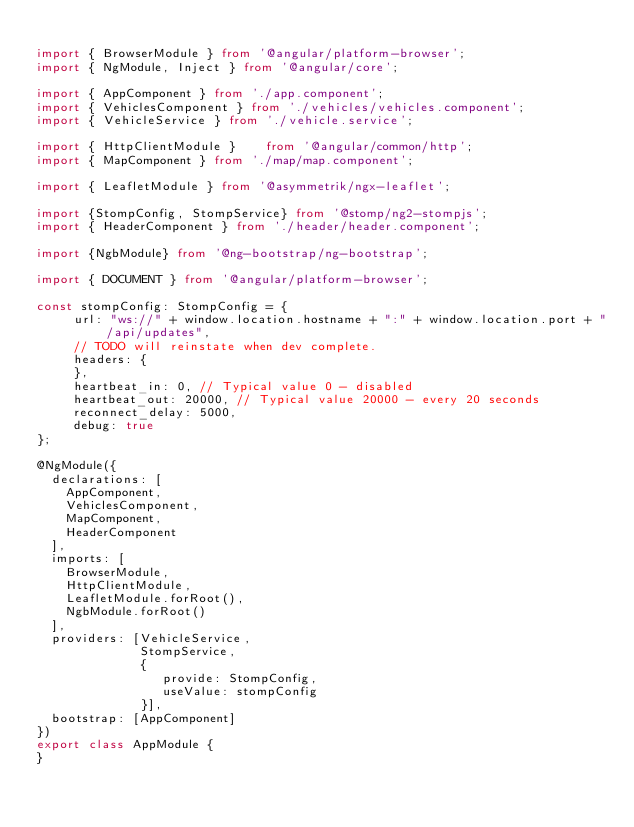<code> <loc_0><loc_0><loc_500><loc_500><_TypeScript_>
import { BrowserModule } from '@angular/platform-browser';
import { NgModule, Inject } from '@angular/core';

import { AppComponent } from './app.component';
import { VehiclesComponent } from './vehicles/vehicles.component';
import { VehicleService } from './vehicle.service';

import { HttpClientModule }    from '@angular/common/http';
import { MapComponent } from './map/map.component';

import { LeafletModule } from '@asymmetrik/ngx-leaflet';

import {StompConfig, StompService} from '@stomp/ng2-stompjs';
import { HeaderComponent } from './header/header.component';

import {NgbModule} from '@ng-bootstrap/ng-bootstrap';

import { DOCUMENT } from '@angular/platform-browser';

const stompConfig: StompConfig = {
     url: "ws://" + window.location.hostname + ":" + window.location.port + "/api/updates",
     // TODO will reinstate when dev complete.
     headers: {
     },
     heartbeat_in: 0, // Typical value 0 - disabled
     heartbeat_out: 20000, // Typical value 20000 - every 20 seconds
     reconnect_delay: 5000,
     debug: true
};

@NgModule({
  declarations: [
    AppComponent,
    VehiclesComponent,
    MapComponent,
    HeaderComponent
  ],
  imports: [
    BrowserModule,
    HttpClientModule,
    LeafletModule.forRoot(),
    NgbModule.forRoot()
  ],
  providers: [VehicleService,
              StompService,
              {
                 provide: StompConfig,
                 useValue: stompConfig
              }],
  bootstrap: [AppComponent]
})
export class AppModule {
}
</code> 